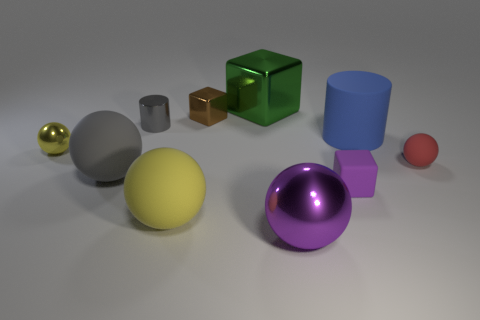Can you describe the lighting and shadows in this scene? The lighting in this scene is diffused, casting soft shadows behind the objects toward the right, suggesting a light source located to the top left of the scene. This type of lighting gives objects a gentle contrast and a realistic appearance. 